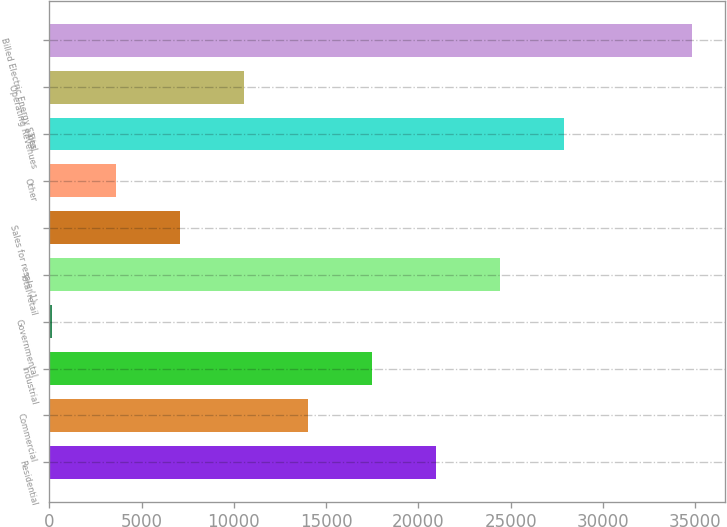Convert chart to OTSL. <chart><loc_0><loc_0><loc_500><loc_500><bar_chart><fcel>Residential<fcel>Commercial<fcel>Industrial<fcel>Governmental<fcel>Total retail<fcel>Sales for resale (1)<fcel>Other<fcel>Total<fcel>Operating Revenues<fcel>Billed Electric Energy Sales<nl><fcel>20970.2<fcel>14031.8<fcel>17501<fcel>155<fcel>24439.4<fcel>7093.4<fcel>3624.2<fcel>27908.6<fcel>10562.6<fcel>34847<nl></chart> 